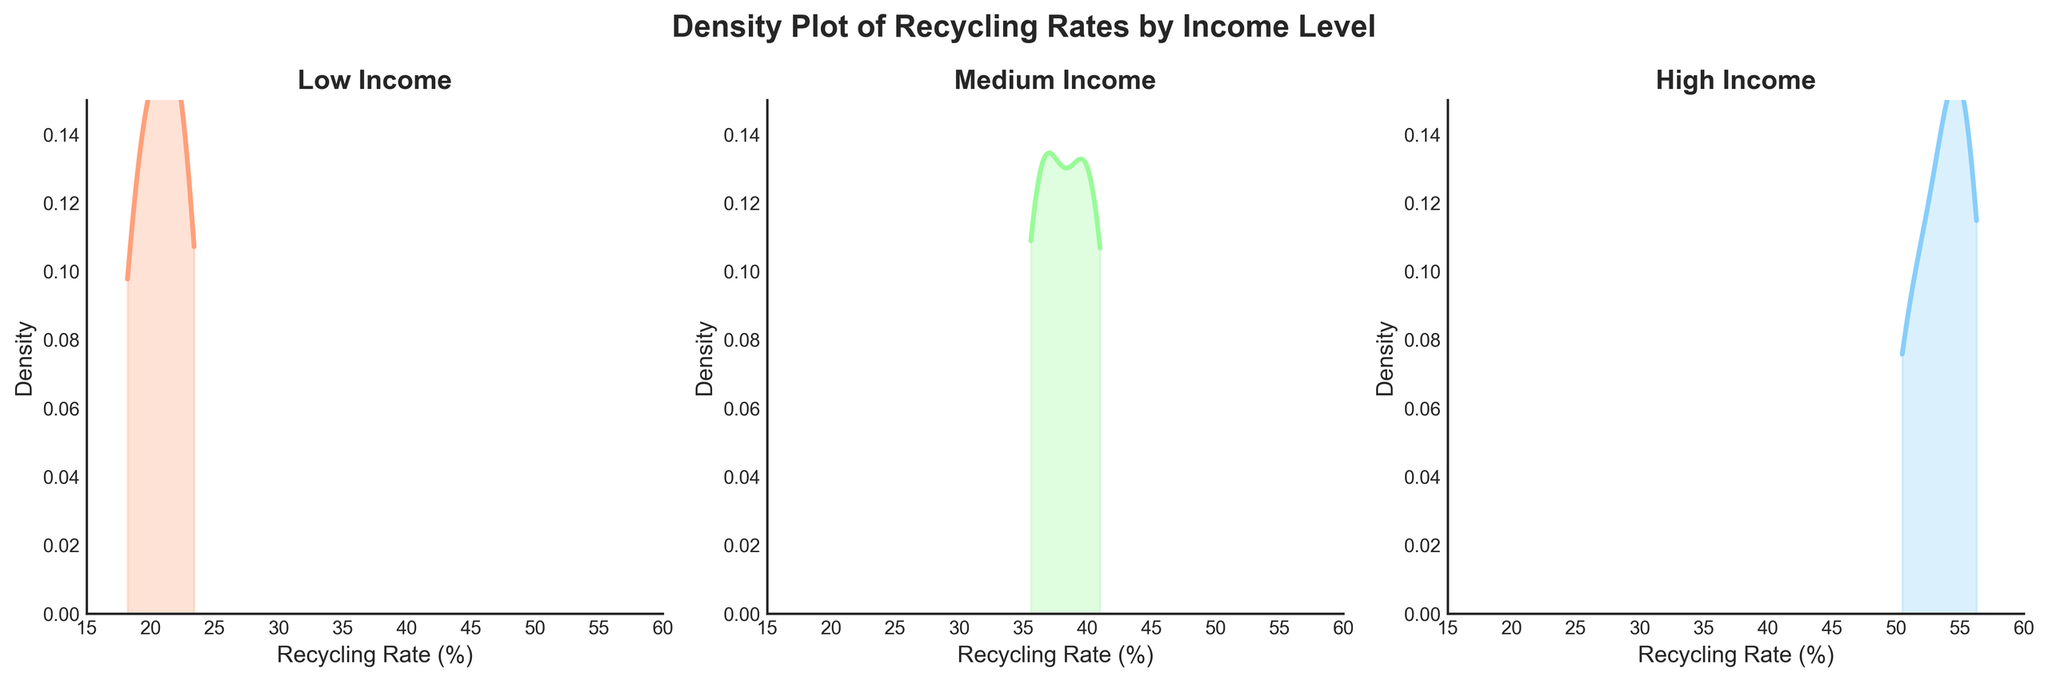What is the title of the figure? The title is clearly written at the top of the figure. It reads "Density Plot of Recycling Rates by Income Level."
Answer: Density Plot of Recycling Rates by Income Level What are the income levels compared in the plot? The plot is subdivided into three panels, each representing a different income level. The titles above each subplot indicate the income levels are "Low Income," "Medium Income," and "High Income."
Answer: Low, Medium, High What is the approximate range of Recycling Rates displayed in the plot? By observing the x-axis of each subplot, the recycling rates range from about 15% to 60%.
Answer: 15% to 60% Which income group has the highest peak density value for recycling rates? Viewing the density plots, the "High Income" group has the highest peak density value, as the curve reaches closer to 0.15 on the y-axis.
Answer: High Income How do the recycling rates of the Low income group compare with the High income group based on density plots? The Low income group's density plot is more spread out and lower compared to the High income group's, which is more concentrated and peaks higher.
Answer: Lower and more spread out Which community has the highest recycling rate in the High income level? Looking at the data, Hamiltonville has the highest recycling rate in the High income level, indicated by 56.3%.
Answer: Hamiltonville What is the range of peak density values in the plots? The peak densities of the curves appear to range between approximately 0.1 and 0.15 across all subplots.
Answer: 0.1 to 0.15 Compare the density curve shapes of the Medium and High income levels. The Medium income density curve is moderately spread out with its peak around 0.1, while the High income density curve is more concentrated with a higher peak nearing 0.15.
Answer: Medium more spread out, High more concentrated What can you infer about the relationship between income level and recycling rates from the plots? The density plots suggest that higher income levels are associated with higher recycling rates, shown by the density peaks shifting rightwards (higher recycling rates) as income levels increase.
Answer: Higher income, higher recycling rates What is the approximate peak density value for the Medium income level? Observing the plot for Medium income, the peak density value is approximately 0.1.
Answer: ~0.1 